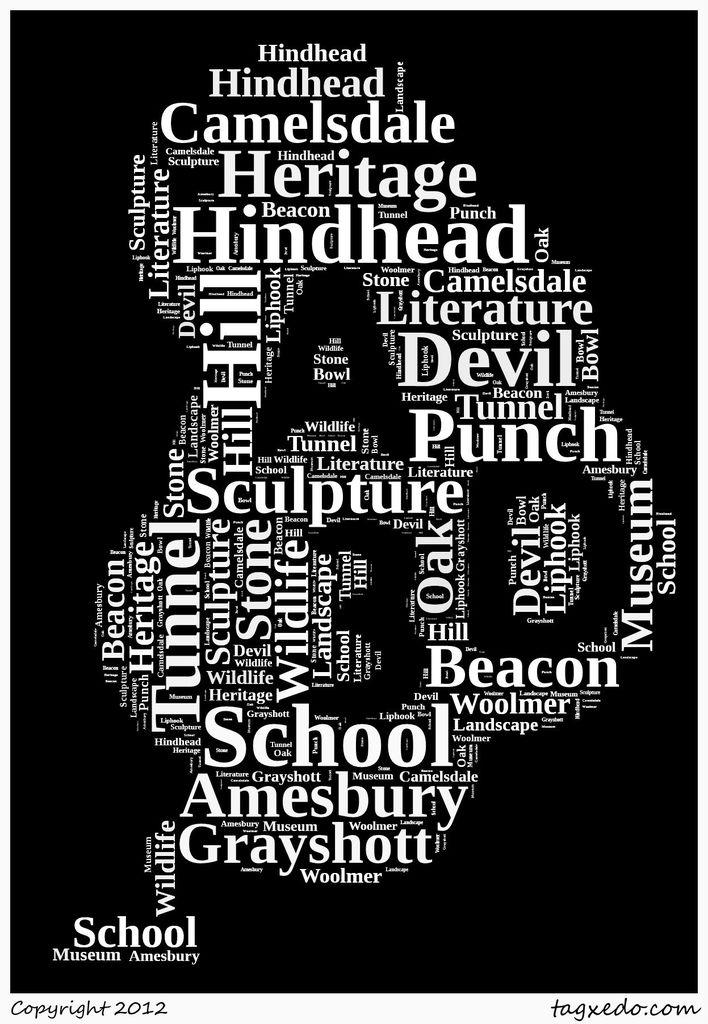What can be seen in the image besides the text? Unfortunately, the provided facts only mention the presence of text in the image. Therefore, we cannot definitively answer what else might be visible in the image. What type of prison is depicted in the image? There is no prison present in the image, as the only fact provided is that there is some text visible in the image. 